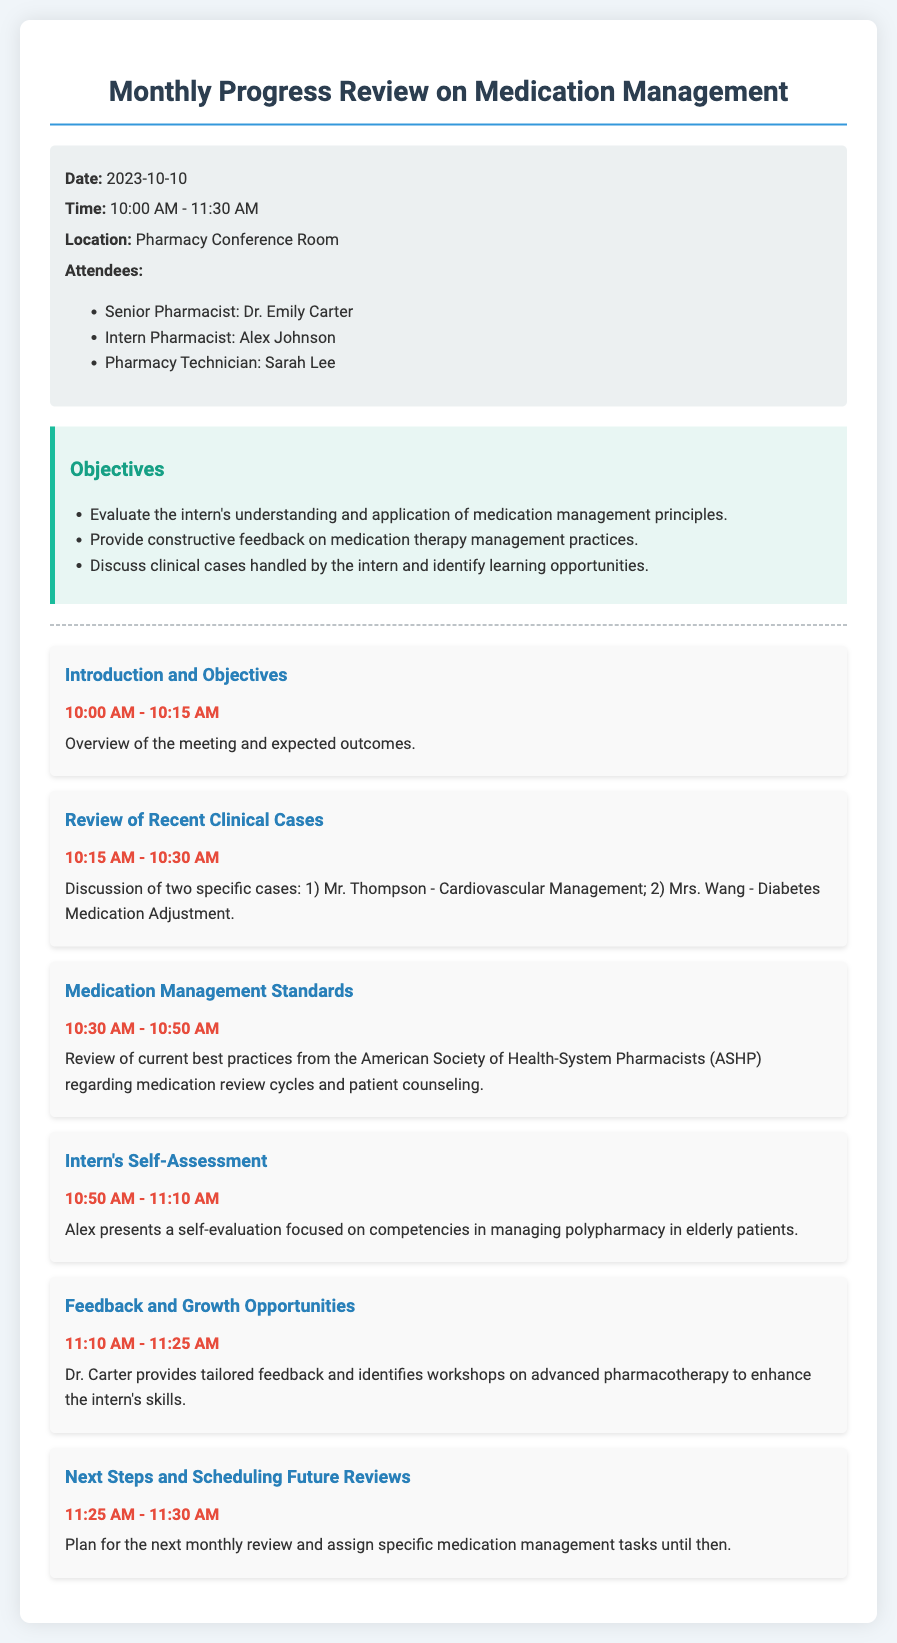What is the date of the meeting? The date of the meeting is clearly stated in the document.
Answer: 2023-10-10 Who is the Senior Pharmacist attending the meeting? The document lists the attendees and specifies their roles.
Answer: Dr. Emily Carter What time does the meeting start? The start time is mentioned in the information section at the beginning of the document.
Answer: 10:00 AM Which two clinical cases are discussed in the meeting? The document details specific cases in the agenda items section.
Answer: Mr. Thompson and Mrs. Wang What is the focus of the Intern's Self-Assessment? The agenda item describes the topic of the intern's presentation in relation to his competencies.
Answer: Managing polypharmacy in elderly patients What type of feedback does Dr. Carter provide? The document outlines this during the feedback session in the agenda items.
Answer: Tailored feedback What is the last agenda item about? The final agenda item concludes the meeting by addressing future planning.
Answer: Next Steps and Scheduling Future Reviews What organization's standards are reviewed in the meeting? The agenda discusses standards from a specific organization during one of the items.
Answer: American Society of Health-System Pharmacists (ASHP) What is scheduled after the Feedback and Growth Opportunities item? The document specifies the next agenda item that follows the feedback session.
Answer: Next Steps and Scheduling Future Reviews 